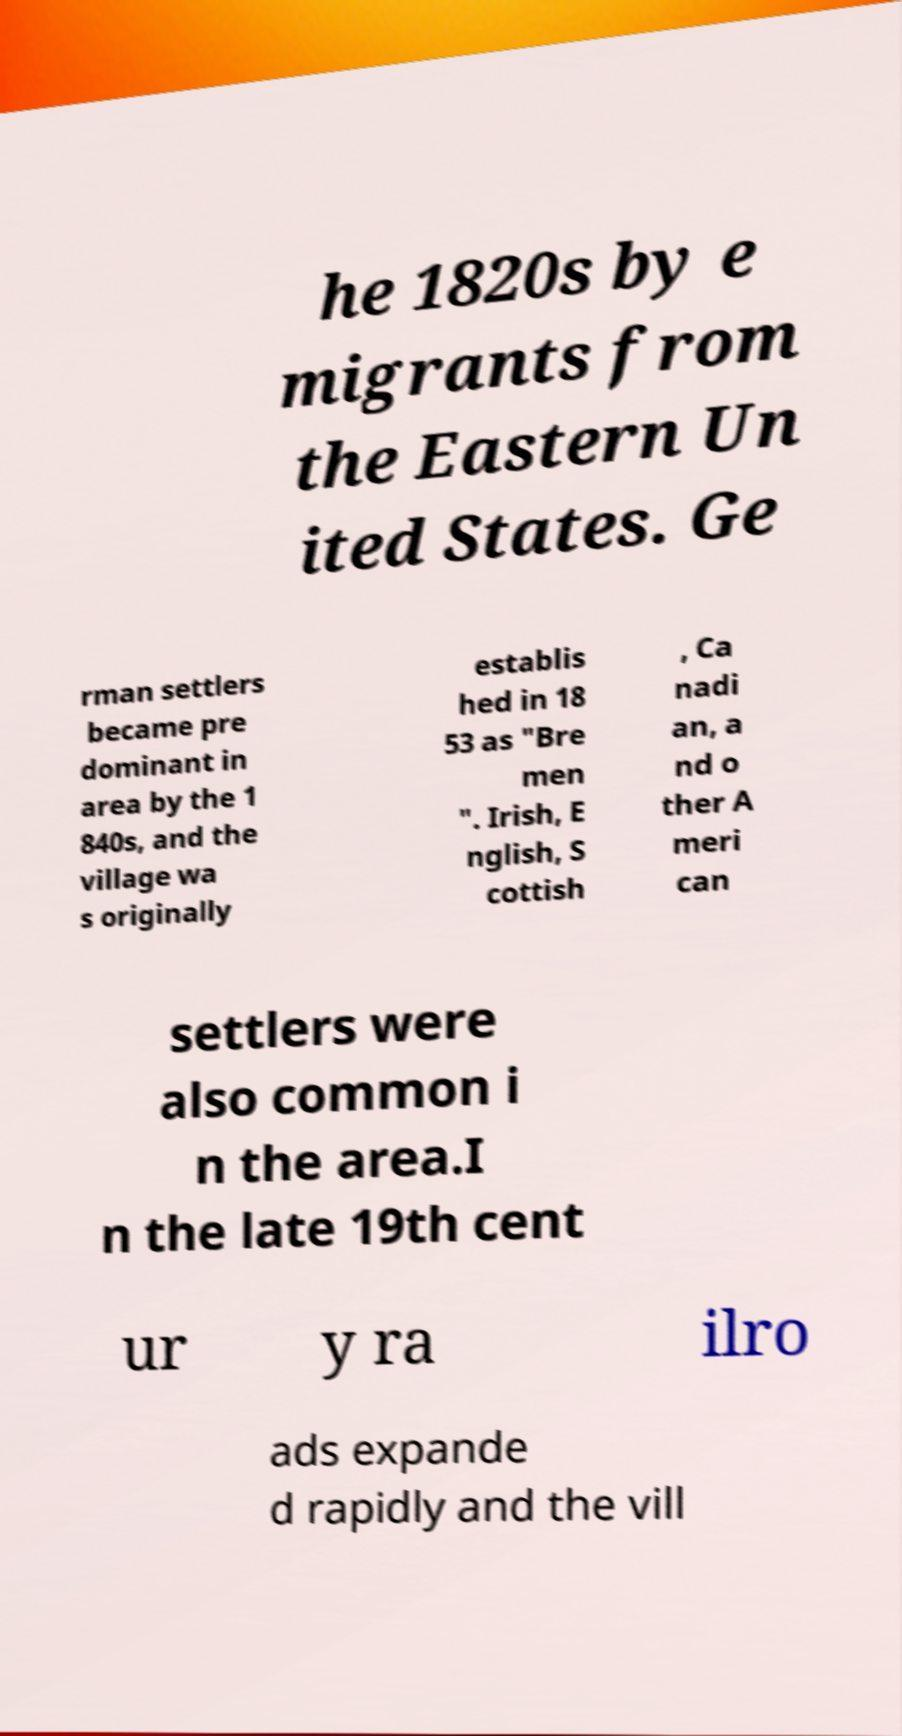For documentation purposes, I need the text within this image transcribed. Could you provide that? he 1820s by e migrants from the Eastern Un ited States. Ge rman settlers became pre dominant in area by the 1 840s, and the village wa s originally establis hed in 18 53 as "Bre men ". Irish, E nglish, S cottish , Ca nadi an, a nd o ther A meri can settlers were also common i n the area.I n the late 19th cent ur y ra ilro ads expande d rapidly and the vill 